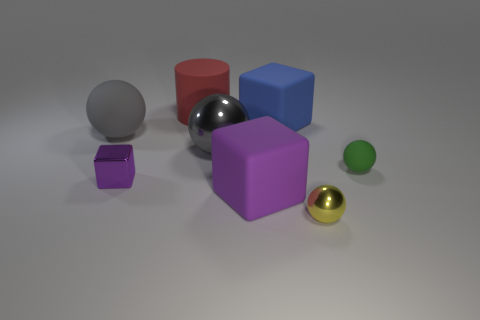Subtract all tiny yellow balls. How many balls are left? 3 Subtract 1 spheres. How many spheres are left? 3 Subtract all cyan balls. Subtract all blue cubes. How many balls are left? 4 Add 1 tiny yellow metallic balls. How many objects exist? 9 Subtract all blocks. How many objects are left? 5 Add 1 big red matte objects. How many big red matte objects are left? 2 Add 3 tiny blue cylinders. How many tiny blue cylinders exist? 3 Subtract 1 yellow balls. How many objects are left? 7 Subtract all tiny yellow balls. Subtract all tiny rubber balls. How many objects are left? 6 